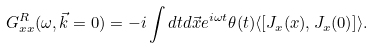<formula> <loc_0><loc_0><loc_500><loc_500>G ^ { R } _ { x x } ( \omega , \vec { k } = 0 ) = - i \int d t d \vec { x } e ^ { i \omega t } \theta ( t ) \langle [ J _ { x } ( x ) , J _ { x } ( 0 ) ] \rangle .</formula> 